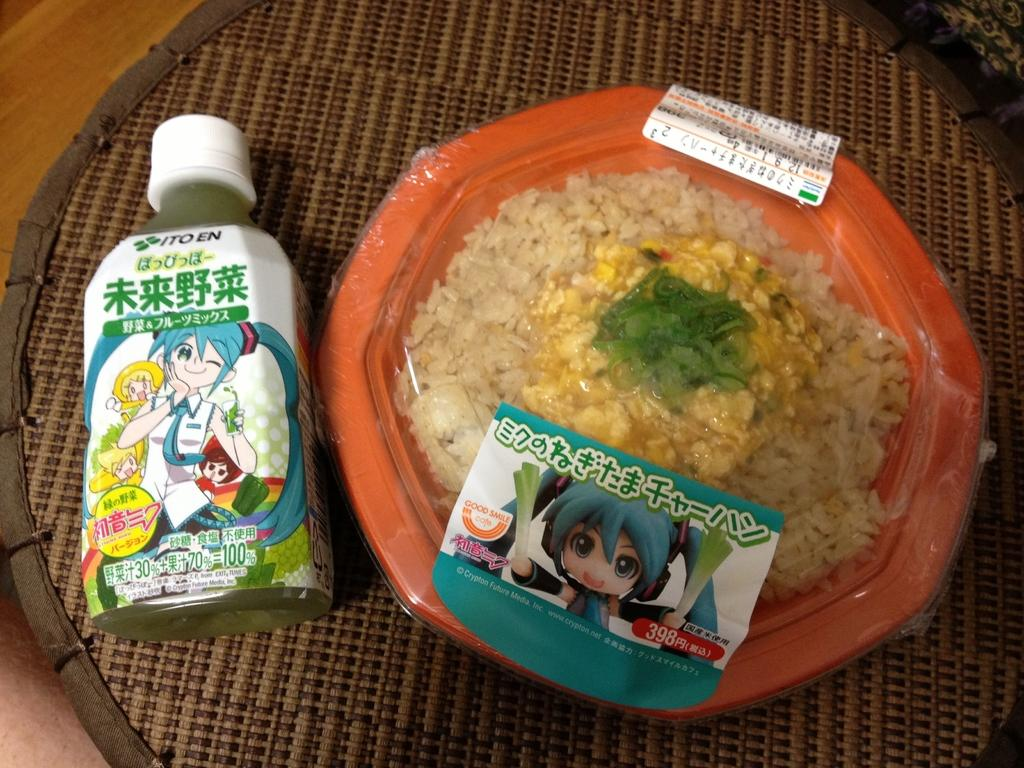What can be seen in the image that is used for holding liquids? There is a bottle in the image that is used for holding liquids. What type of food is in the bowl in the image? There is food in a bowl in the image, but the specific type of food is not mentioned. How is the bowl with food covered in the image? The bowl is covered with a polythene cover in the image. What is present in the image that is used for placing objects on? There is a mat in the image that is used for placing objects on. Where is the mat located in the image? The mat is placed on a surface in the image. Can you see any squirrels swimming in the ocean in the image? There is no ocean or squirrels present in the image. 